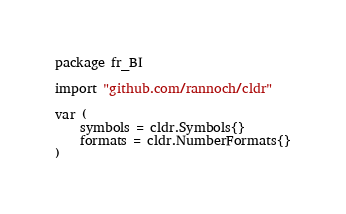Convert code to text. <code><loc_0><loc_0><loc_500><loc_500><_Go_>package fr_BI

import "github.com/rannoch/cldr"

var (
	symbols = cldr.Symbols{}
	formats = cldr.NumberFormats{}
)
</code> 